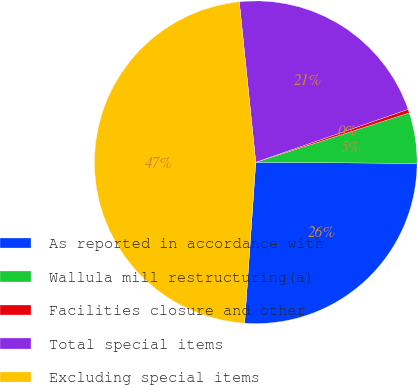Convert chart. <chart><loc_0><loc_0><loc_500><loc_500><pie_chart><fcel>As reported in accordance with<fcel>Wallula mill restructuring(a)<fcel>Facilities closure and other<fcel>Total special items<fcel>Excluding special items<nl><fcel>25.99%<fcel>5.06%<fcel>0.37%<fcel>21.3%<fcel>47.27%<nl></chart> 